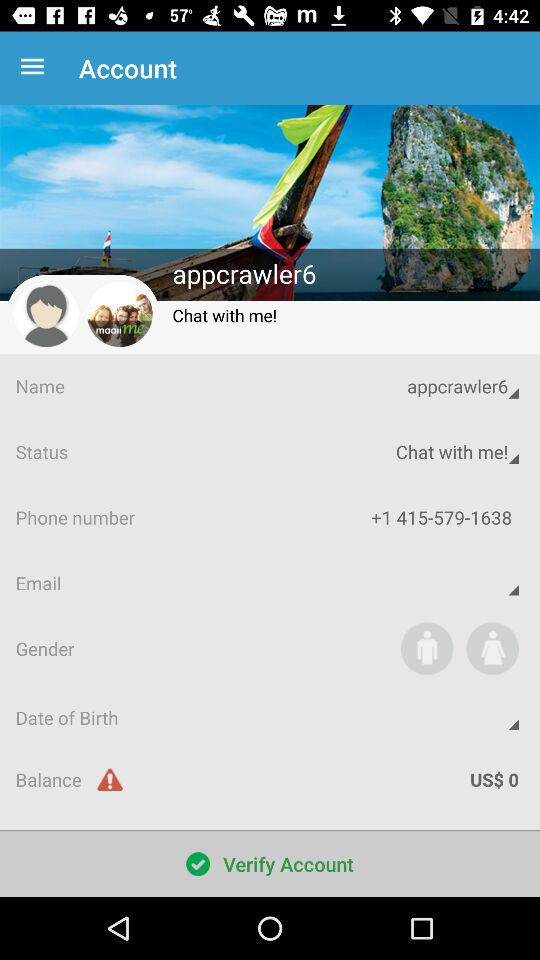What is the status? The status is "Chat with me!". 